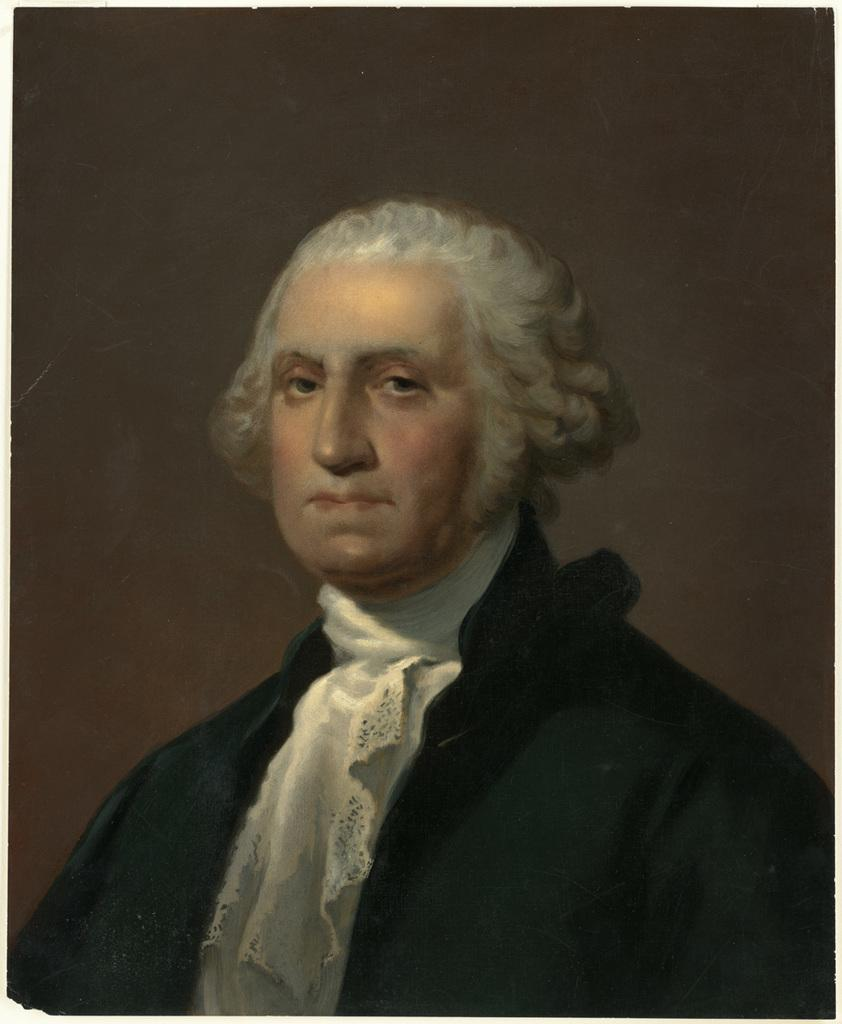Who is present in the image? There is a man in the image. What is the man wearing? The man is wearing a black and white dress. What color is the background of the image? The background of the image is brown. How much money is the man holding in the image? There is no indication of money in the image; the man is wearing a black and white dress and standing in front of a brown background. 